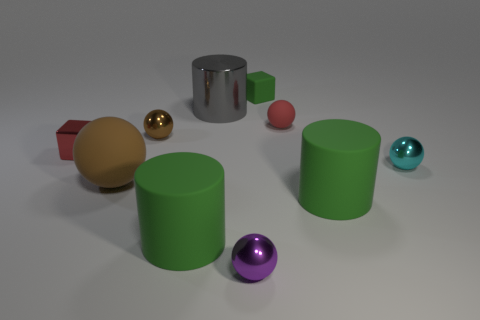Subtract all cyan balls. How many balls are left? 4 Subtract all blocks. How many objects are left? 8 Add 5 small rubber objects. How many small rubber objects are left? 7 Add 8 purple balls. How many purple balls exist? 9 Subtract 0 blue cubes. How many objects are left? 10 Subtract all tiny gray metallic spheres. Subtract all purple things. How many objects are left? 9 